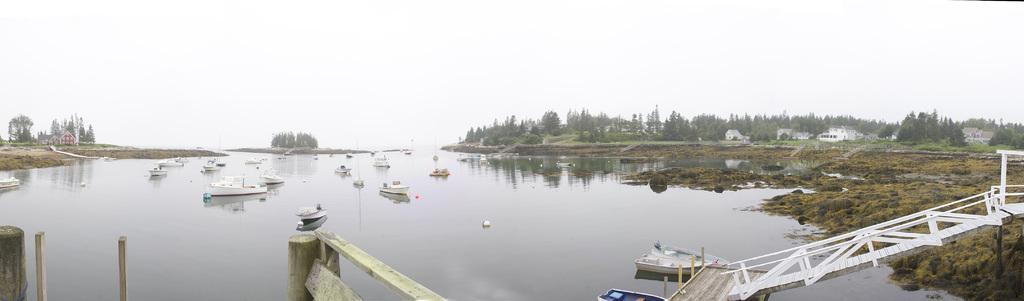In one or two sentences, can you explain what this image depicts? In the image we can see there is water and there are boats standing in the water. There are stairs and bridge. The ground is covered with grass. Behind there are buildings and lot of trees at the back. There is a clear sky. 